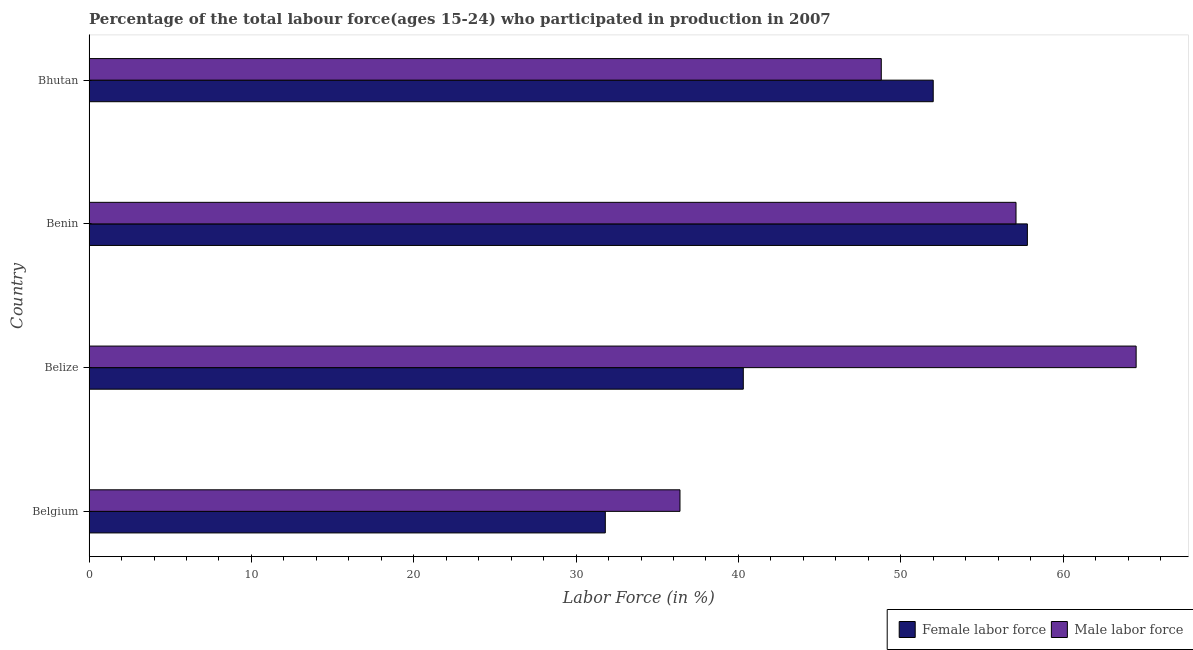How many different coloured bars are there?
Provide a short and direct response. 2. Are the number of bars per tick equal to the number of legend labels?
Ensure brevity in your answer.  Yes. Are the number of bars on each tick of the Y-axis equal?
Offer a terse response. Yes. How many bars are there on the 2nd tick from the top?
Offer a very short reply. 2. What is the label of the 3rd group of bars from the top?
Your answer should be compact. Belize. Across all countries, what is the maximum percentage of female labor force?
Provide a short and direct response. 57.8. Across all countries, what is the minimum percentage of female labor force?
Provide a short and direct response. 31.8. In which country was the percentage of male labour force maximum?
Keep it short and to the point. Belize. What is the total percentage of male labour force in the graph?
Your answer should be compact. 206.8. What is the difference between the percentage of female labor force in Benin and that in Bhutan?
Your answer should be compact. 5.8. What is the difference between the percentage of male labour force in Benin and the percentage of female labor force in Belize?
Your answer should be very brief. 16.8. What is the average percentage of male labour force per country?
Provide a succinct answer. 51.7. What is the difference between the percentage of female labor force and percentage of male labour force in Benin?
Your response must be concise. 0.7. In how many countries, is the percentage of female labor force greater than 60 %?
Keep it short and to the point. 0. What is the ratio of the percentage of male labour force in Belgium to that in Benin?
Give a very brief answer. 0.64. Is the difference between the percentage of female labor force in Benin and Bhutan greater than the difference between the percentage of male labour force in Benin and Bhutan?
Provide a short and direct response. No. What is the difference between the highest and the second highest percentage of female labor force?
Your answer should be compact. 5.8. What is the difference between the highest and the lowest percentage of male labour force?
Provide a succinct answer. 28.1. Is the sum of the percentage of female labor force in Belgium and Bhutan greater than the maximum percentage of male labour force across all countries?
Keep it short and to the point. Yes. What does the 2nd bar from the top in Benin represents?
Give a very brief answer. Female labor force. What does the 1st bar from the bottom in Bhutan represents?
Offer a very short reply. Female labor force. How many bars are there?
Your response must be concise. 8. Are all the bars in the graph horizontal?
Offer a very short reply. Yes. How many countries are there in the graph?
Provide a short and direct response. 4. Are the values on the major ticks of X-axis written in scientific E-notation?
Provide a succinct answer. No. Does the graph contain grids?
Ensure brevity in your answer.  No. Where does the legend appear in the graph?
Give a very brief answer. Bottom right. What is the title of the graph?
Offer a terse response. Percentage of the total labour force(ages 15-24) who participated in production in 2007. Does "Imports" appear as one of the legend labels in the graph?
Offer a very short reply. No. What is the label or title of the X-axis?
Ensure brevity in your answer.  Labor Force (in %). What is the Labor Force (in %) in Female labor force in Belgium?
Provide a short and direct response. 31.8. What is the Labor Force (in %) in Male labor force in Belgium?
Offer a very short reply. 36.4. What is the Labor Force (in %) of Female labor force in Belize?
Your response must be concise. 40.3. What is the Labor Force (in %) of Male labor force in Belize?
Give a very brief answer. 64.5. What is the Labor Force (in %) in Female labor force in Benin?
Provide a succinct answer. 57.8. What is the Labor Force (in %) of Male labor force in Benin?
Keep it short and to the point. 57.1. What is the Labor Force (in %) in Male labor force in Bhutan?
Ensure brevity in your answer.  48.8. Across all countries, what is the maximum Labor Force (in %) in Female labor force?
Make the answer very short. 57.8. Across all countries, what is the maximum Labor Force (in %) of Male labor force?
Keep it short and to the point. 64.5. Across all countries, what is the minimum Labor Force (in %) of Female labor force?
Provide a succinct answer. 31.8. Across all countries, what is the minimum Labor Force (in %) in Male labor force?
Keep it short and to the point. 36.4. What is the total Labor Force (in %) in Female labor force in the graph?
Give a very brief answer. 181.9. What is the total Labor Force (in %) in Male labor force in the graph?
Give a very brief answer. 206.8. What is the difference between the Labor Force (in %) of Male labor force in Belgium and that in Belize?
Give a very brief answer. -28.1. What is the difference between the Labor Force (in %) in Male labor force in Belgium and that in Benin?
Your response must be concise. -20.7. What is the difference between the Labor Force (in %) in Female labor force in Belgium and that in Bhutan?
Keep it short and to the point. -20.2. What is the difference between the Labor Force (in %) of Female labor force in Belize and that in Benin?
Provide a succinct answer. -17.5. What is the difference between the Labor Force (in %) in Male labor force in Belize and that in Benin?
Offer a terse response. 7.4. What is the difference between the Labor Force (in %) of Male labor force in Belize and that in Bhutan?
Offer a terse response. 15.7. What is the difference between the Labor Force (in %) in Female labor force in Benin and that in Bhutan?
Ensure brevity in your answer.  5.8. What is the difference between the Labor Force (in %) of Female labor force in Belgium and the Labor Force (in %) of Male labor force in Belize?
Your answer should be compact. -32.7. What is the difference between the Labor Force (in %) of Female labor force in Belgium and the Labor Force (in %) of Male labor force in Benin?
Offer a terse response. -25.3. What is the difference between the Labor Force (in %) in Female labor force in Belize and the Labor Force (in %) in Male labor force in Benin?
Make the answer very short. -16.8. What is the difference between the Labor Force (in %) in Female labor force in Belize and the Labor Force (in %) in Male labor force in Bhutan?
Your answer should be compact. -8.5. What is the difference between the Labor Force (in %) of Female labor force in Benin and the Labor Force (in %) of Male labor force in Bhutan?
Give a very brief answer. 9. What is the average Labor Force (in %) in Female labor force per country?
Your answer should be very brief. 45.48. What is the average Labor Force (in %) in Male labor force per country?
Your answer should be very brief. 51.7. What is the difference between the Labor Force (in %) in Female labor force and Labor Force (in %) in Male labor force in Belgium?
Ensure brevity in your answer.  -4.6. What is the difference between the Labor Force (in %) of Female labor force and Labor Force (in %) of Male labor force in Belize?
Make the answer very short. -24.2. What is the ratio of the Labor Force (in %) in Female labor force in Belgium to that in Belize?
Offer a terse response. 0.79. What is the ratio of the Labor Force (in %) of Male labor force in Belgium to that in Belize?
Ensure brevity in your answer.  0.56. What is the ratio of the Labor Force (in %) of Female labor force in Belgium to that in Benin?
Your response must be concise. 0.55. What is the ratio of the Labor Force (in %) of Male labor force in Belgium to that in Benin?
Provide a short and direct response. 0.64. What is the ratio of the Labor Force (in %) in Female labor force in Belgium to that in Bhutan?
Ensure brevity in your answer.  0.61. What is the ratio of the Labor Force (in %) of Male labor force in Belgium to that in Bhutan?
Keep it short and to the point. 0.75. What is the ratio of the Labor Force (in %) in Female labor force in Belize to that in Benin?
Offer a terse response. 0.7. What is the ratio of the Labor Force (in %) in Male labor force in Belize to that in Benin?
Your answer should be very brief. 1.13. What is the ratio of the Labor Force (in %) in Female labor force in Belize to that in Bhutan?
Provide a short and direct response. 0.78. What is the ratio of the Labor Force (in %) of Male labor force in Belize to that in Bhutan?
Offer a terse response. 1.32. What is the ratio of the Labor Force (in %) in Female labor force in Benin to that in Bhutan?
Keep it short and to the point. 1.11. What is the ratio of the Labor Force (in %) in Male labor force in Benin to that in Bhutan?
Provide a short and direct response. 1.17. What is the difference between the highest and the second highest Labor Force (in %) of Female labor force?
Offer a very short reply. 5.8. What is the difference between the highest and the lowest Labor Force (in %) in Female labor force?
Keep it short and to the point. 26. What is the difference between the highest and the lowest Labor Force (in %) of Male labor force?
Offer a terse response. 28.1. 